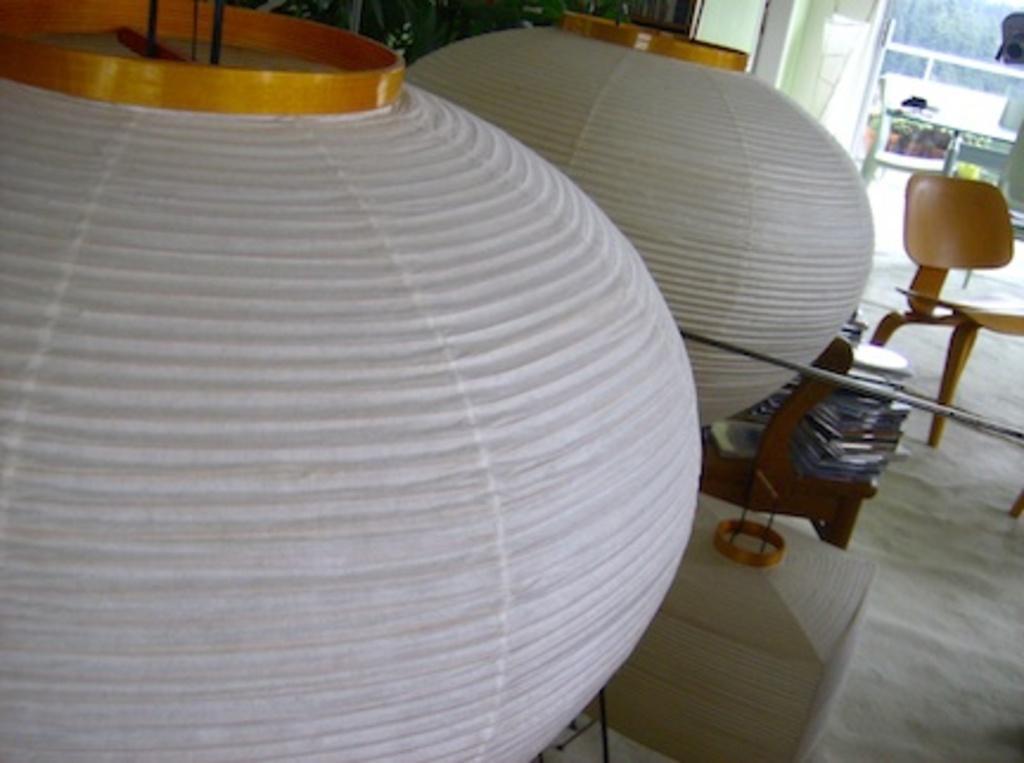Can you describe this image briefly? In this image they are objects that look like lamps in the front. There is floor at the bottom. There are cars, there is a chair with objects, there is a table, there are trees on the right corner. 